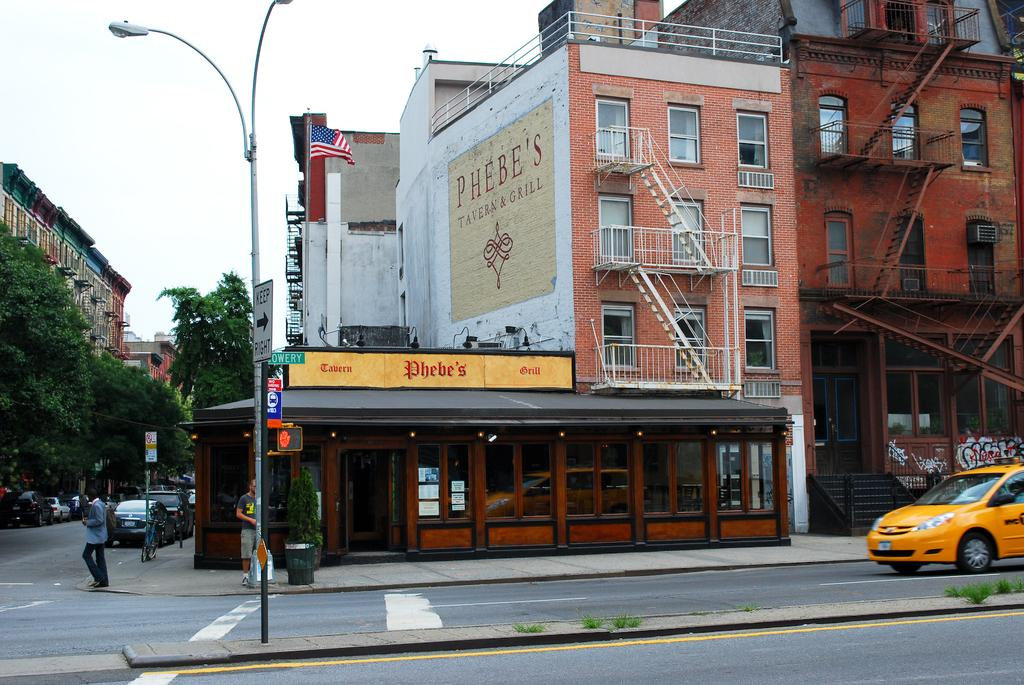<image>
Present a compact description of the photo's key features. An urban street scene of a restaurant named Phebe's 